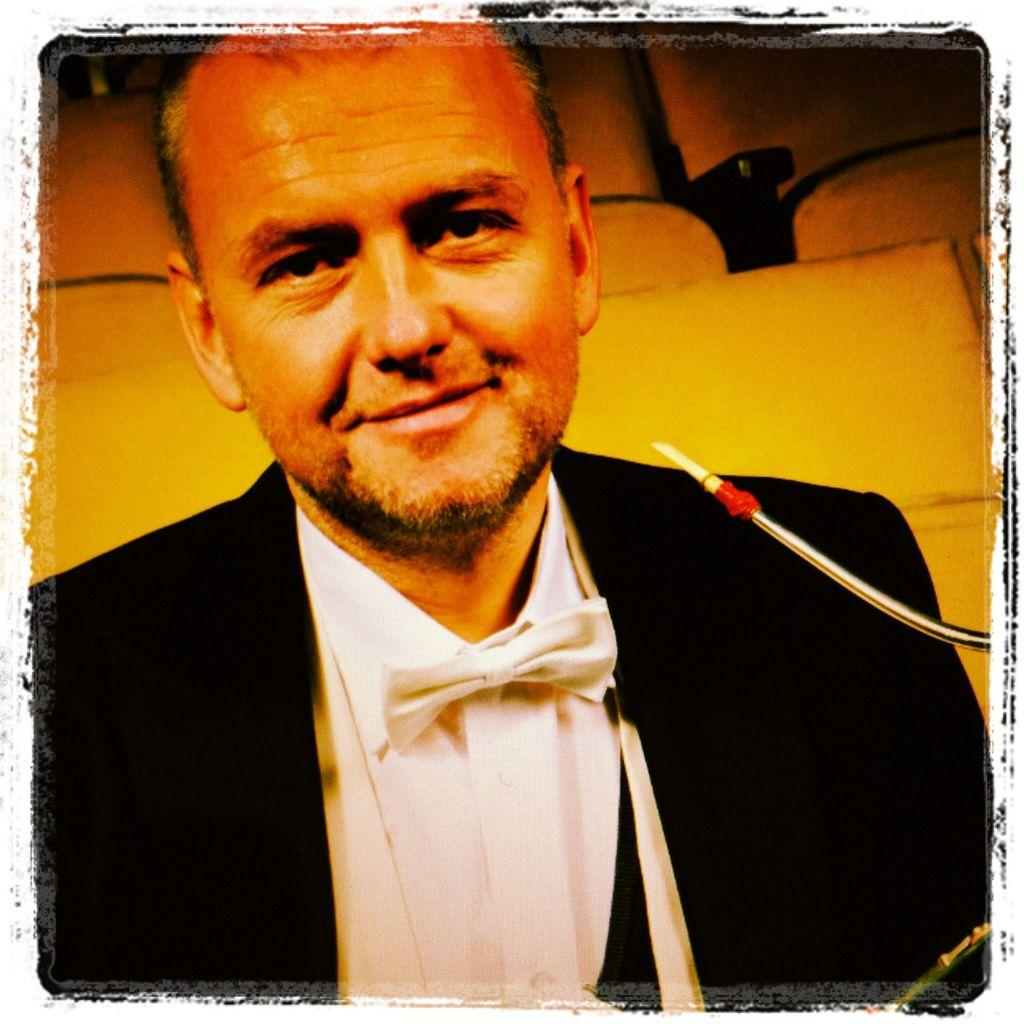Who or what is the main subject of the image? There is a person in the image. What is the person wearing on their upper body? The person is wearing a black blazer and a white shirt. What can be seen in the background of the image? There are chairs in the background of the image. What letter does the person drop on the floor in the image? There is no letter present in the image, and the person does not drop anything on the floor. 